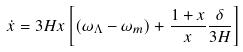Convert formula to latex. <formula><loc_0><loc_0><loc_500><loc_500>\dot { x } = 3 H x \left [ ( \omega _ { \Lambda } - \omega _ { m } ) + \frac { 1 + x } { x } \frac { \delta } { 3 H } \right ]</formula> 